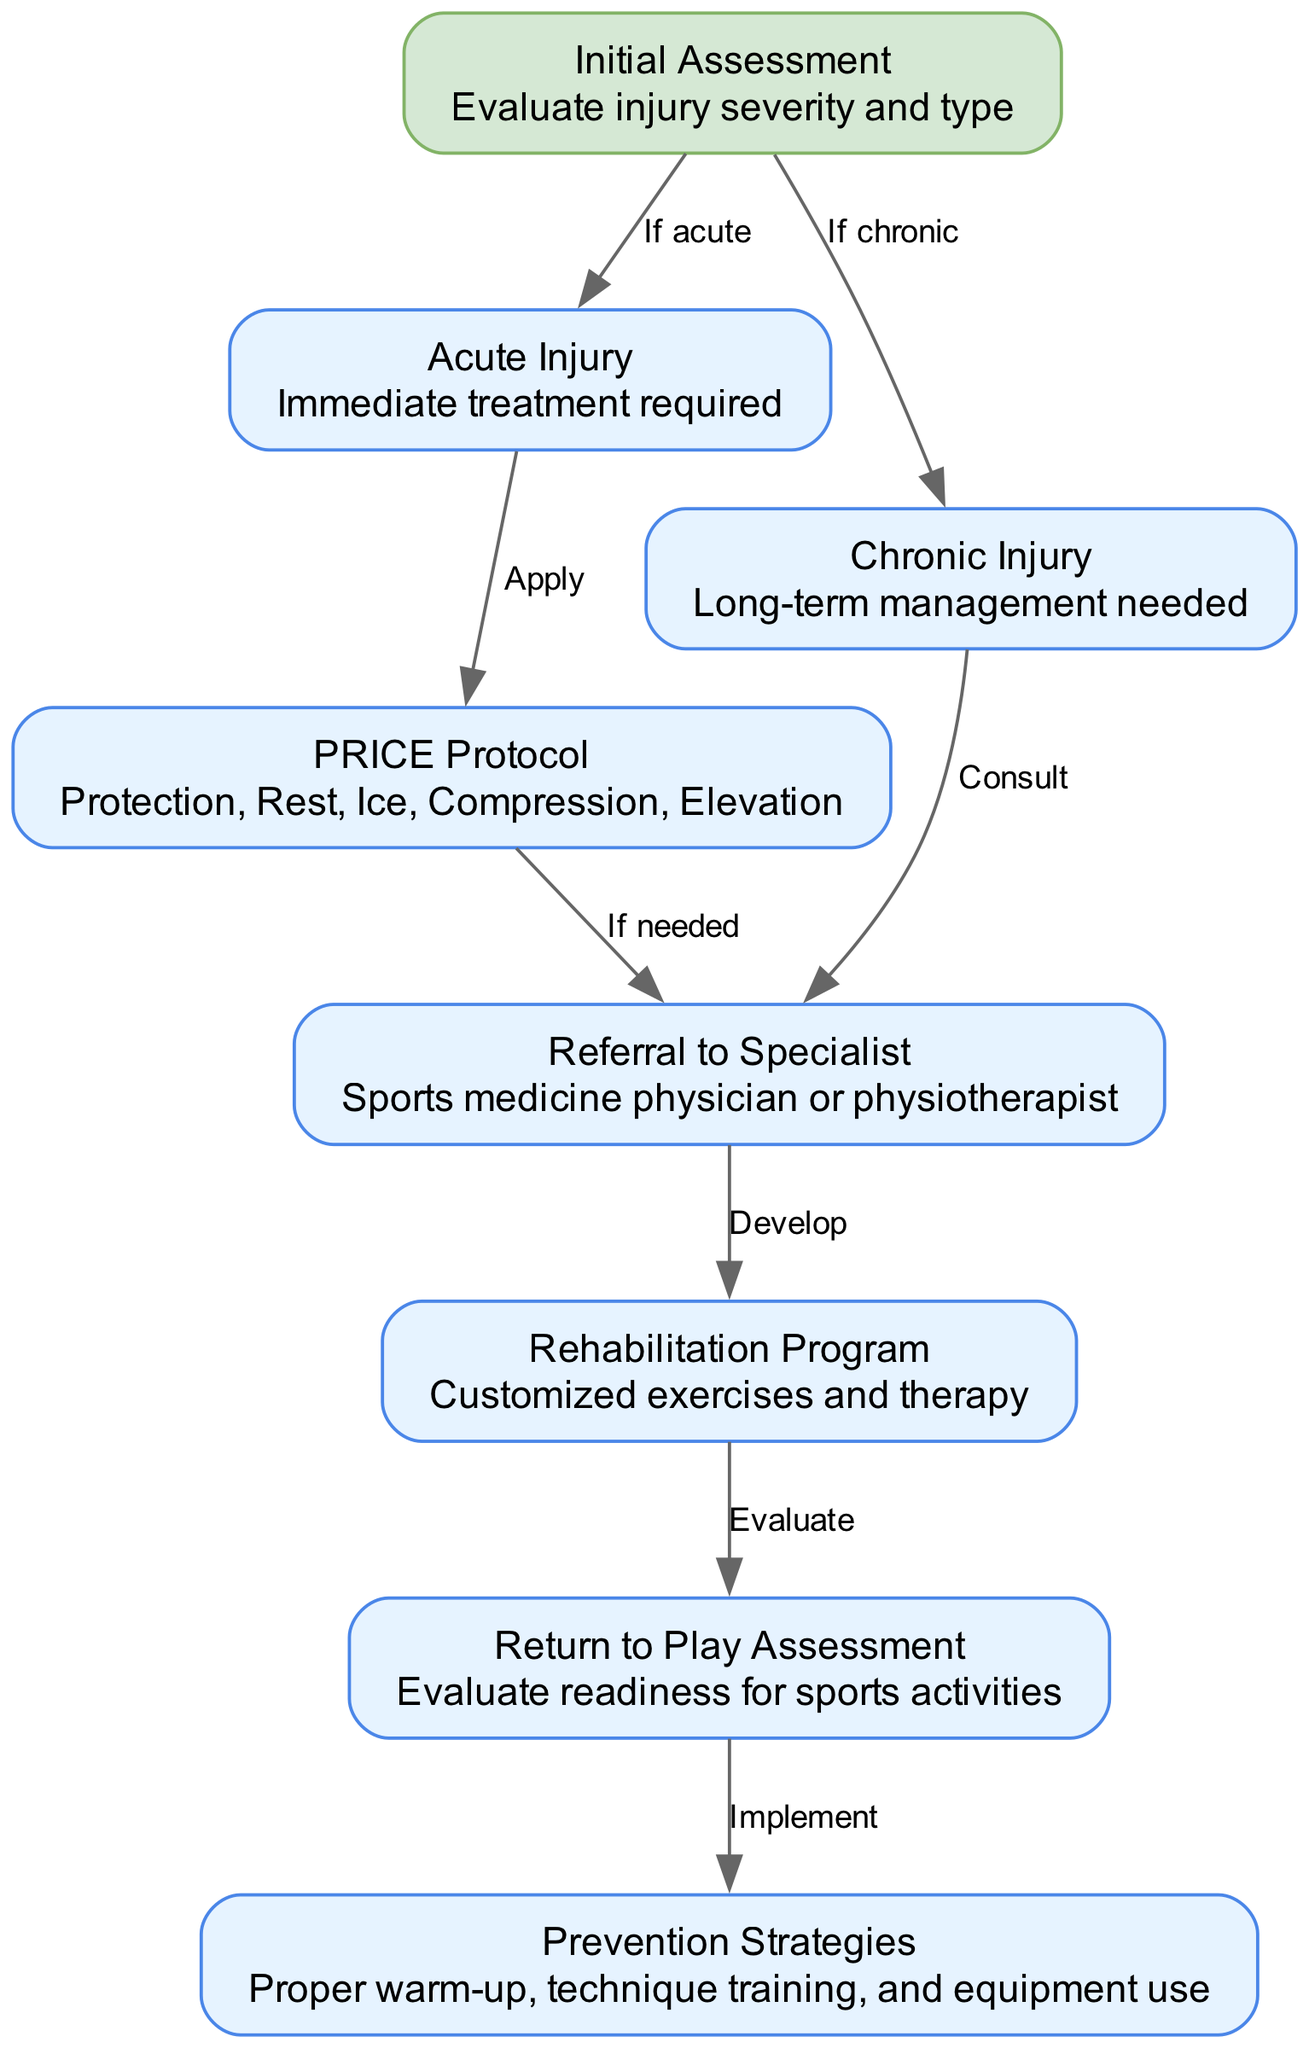What is the first step in the clinical pathway? The first step is the "Initial Assessment," which is indicated as the starting node in the diagram.
Answer: Initial Assessment How many nodes are there in the diagram? By counting each unique node listed in the data, we find that there are a total of 8 nodes present.
Answer: 8 What type of injury requires immediate treatment? The diagram indicates that an "Acute Injury" is the type that requires immediate treatment, following the "Initial Assessment" node.
Answer: Acute Injury What follows after the "Rehabilitation Program"? According to the diagram flow, the next step after the "Rehabilitation Program" is the "Return to Play Assessment."
Answer: Return to Play Assessment What treatment is applied for an acute injury? For an acute injury, the diagram specifies that the "PRICE Protocol" is applied immediately after the injury is assessed.
Answer: PRICE Protocol If the injury is chronic, what is the recommended action? The diagram shows that for a chronic injury, a "Referral to Specialist" is recommended for consultation, as indicated in the flow from that node.
Answer: Referral to Specialist What is one prevention strategy mentioned in the pathway? The pathway provides "Proper warm-up, technique training, and equipment use" as prevention strategies, showing how to avoid injuries in the first place.
Answer: Proper warm-up, technique training, and equipment use How is readiness for sports activities evaluated? The diagram indicates that readiness for sports activities is evaluated during the "Return to Play Assessment" phase after rehabilitation is completed.
Answer: Return to Play Assessment 